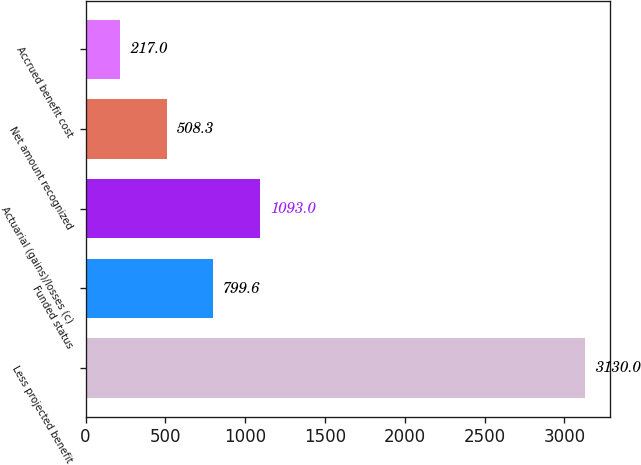Convert chart to OTSL. <chart><loc_0><loc_0><loc_500><loc_500><bar_chart><fcel>Less projected benefit<fcel>Funded status<fcel>Actuarial (gains)/losses (c)<fcel>Net amount recognized<fcel>Accrued benefit cost<nl><fcel>3130<fcel>799.6<fcel>1093<fcel>508.3<fcel>217<nl></chart> 